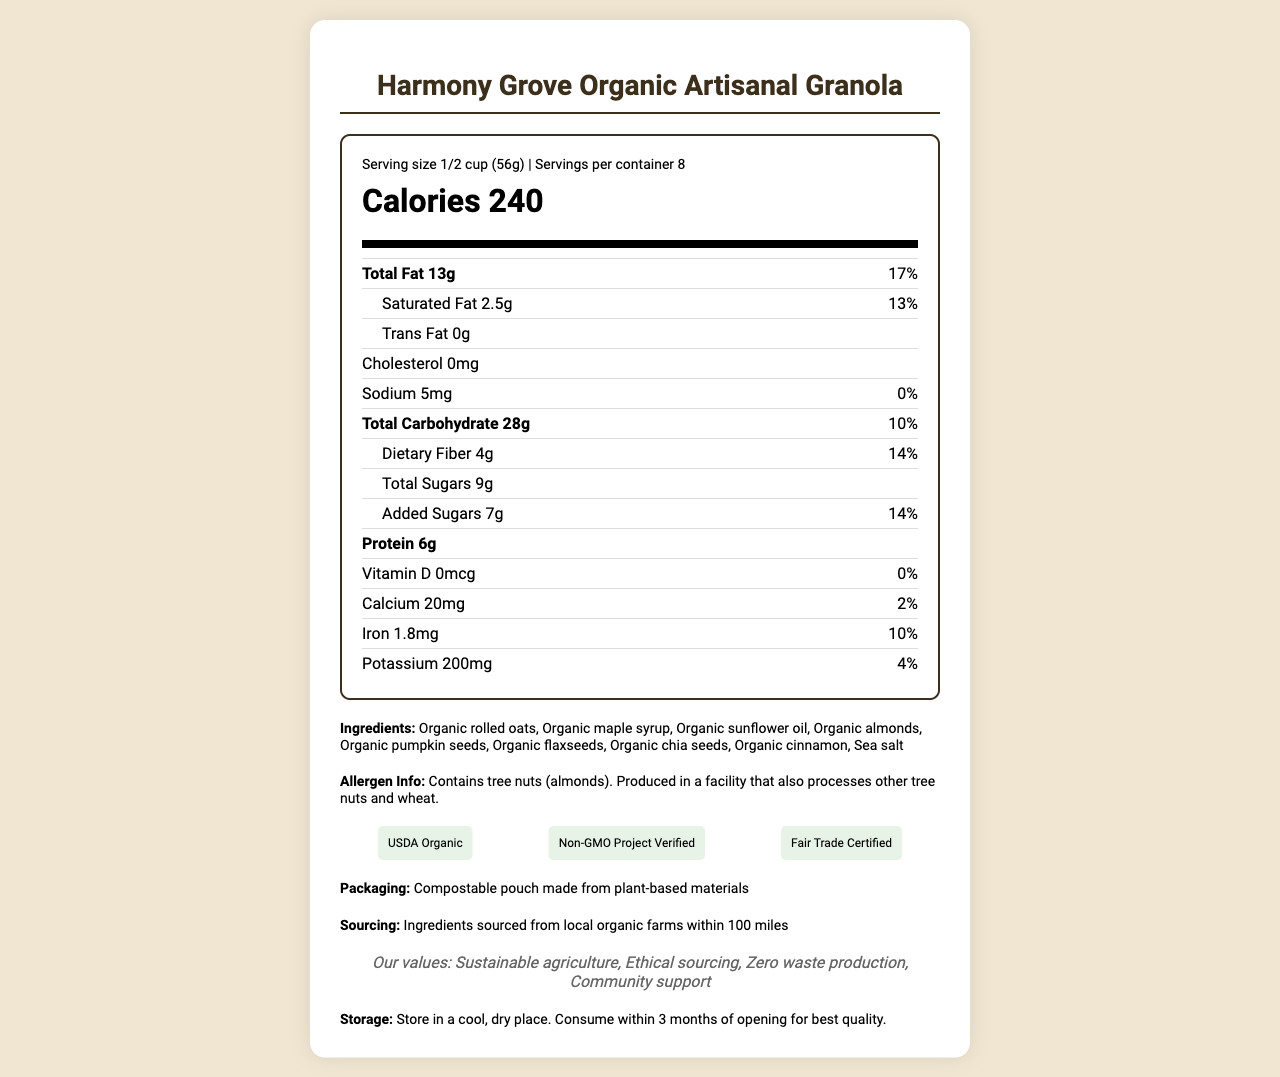what is the serving size? The serving size is mentioned at the top under the nutrition header, "Serving size 1/2 cup (56g)".
Answer: 1/2 cup (56g) how many servings are in a container? The servings per container are listed next to the serving size information, "Servings per container 8".
Answer: 8 what is the amount of dietary fiber per serving? Dietary fiber is listed under the total carbohydrate section with an amount of 4g and a daily value of 14%.
Answer: 4g how many calories are in one serving? The calories per serving are prominently displayed in large font at the top in the calories section, "Calories 240".
Answer: 240 what certifications does the product have? Certifications are listed under the certifications section.
Answer: USDA Organic, Non-GMO Project Verified, Fair Trade Certified what is the percentage daily value of calcium per serving? A. 0% B. 2% C. 5% The percentage daily value for calcium is listed under the calcium section, "daily value 2%".
Answer: B which of the following is not listed as an ingredient? A. Sea salt B. Organic rolled oats C. Organic honey D. Organic chia seeds Organic honey is not listed among the ingredients, while the other three options are, thereby making "C. Organic honey" the correct choice.
Answer: C does this product contain any allergens? The allergen information is listed in the document under the allergen info section, "Contains tree nuts (almonds). Produced in a facility that also processes other tree nuts and wheat".
Answer: Yes summarize the document. The document provides detailed nutritional information about the product, mentions its organic and locally sourced ingredients, highlights its certifications, sustainable packaging, and company values, and includes storage instructions and allergen information.
Answer: Harmony Grove Organic Artisanal Granola is an organic, sustainably produced granola with a serving size of 1/2 cup and 8 servings per container. It contains 240 calories per serving and provides detailed nutritional information, including fat, carbohydrates, and proteins. The ingredients are organic and locally sourced. The product holds multiple certifications and comes in eco-friendly packaging. what is the daily value of protein per serving? The document provides the amount of protein per serving (6g) but does not specify the percentage daily value for protein.
Answer: Not enough information how should the granola be stored after opening? Storage instructions are listed towards the bottom of the document under storage instructions section.
Answer: Store in a cool, dry place. Consume within 3 months of opening for best quality. which certification is not listed? A. USDA Organic B. Non-GMO Project Verified C. Fair Trade Certified D. Gluten-Free Certified The document lists "USDA Organic," "Non-GMO Project Verified," and "Fair Trade Certified," but "Gluten-Free Certified" is not listed, making "D" the correct option.
Answer: D is trans fat present in the product? The document explicitly states that the trans fat content is "0g".
Answer: No 